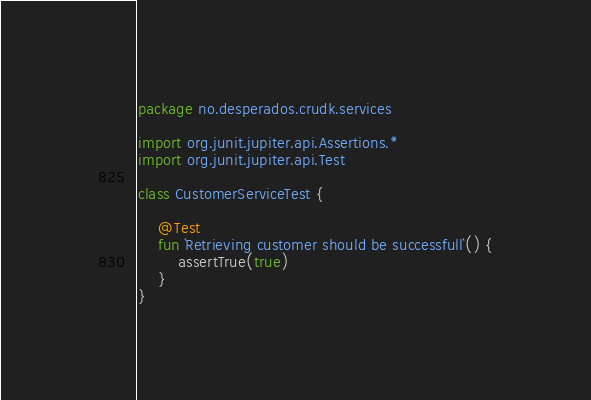Convert code to text. <code><loc_0><loc_0><loc_500><loc_500><_Kotlin_>package no.desperados.crudk.services

import org.junit.jupiter.api.Assertions.*
import org.junit.jupiter.api.Test

class CustomerServiceTest {

    @Test
    fun `Retrieving customer should be successfull`() {
        assertTrue(true)
    }
}</code> 